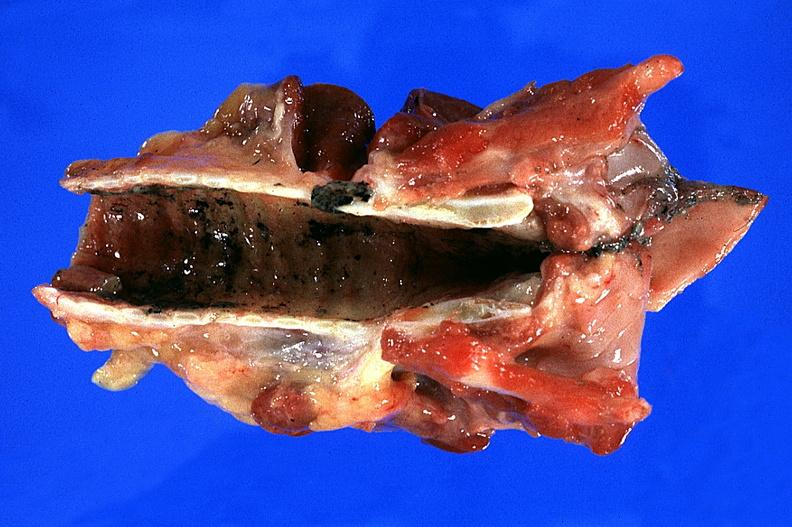where is this?
Answer the question using a single word or phrase. Lung 